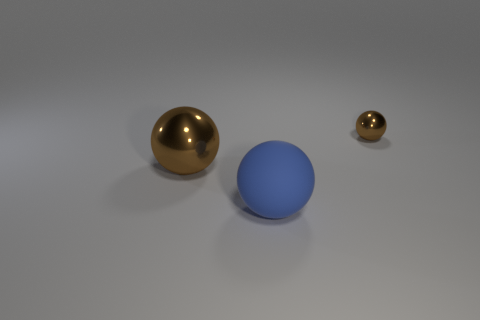There is a thing that is the same color as the big metal sphere; what is its shape? sphere 